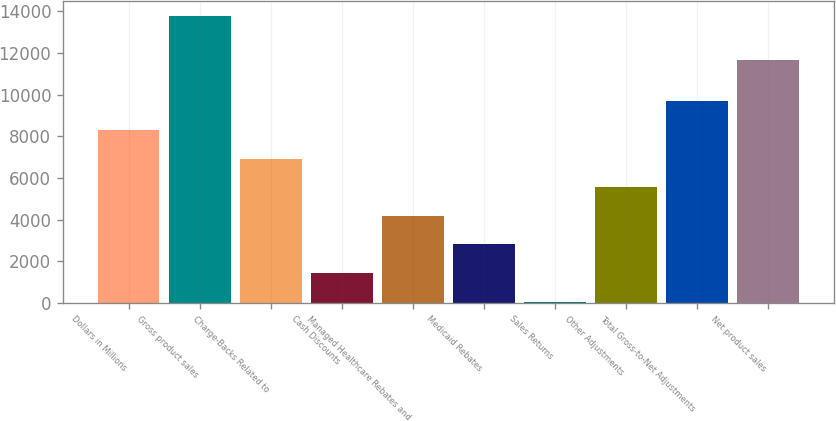Convert chart to OTSL. <chart><loc_0><loc_0><loc_500><loc_500><bar_chart><fcel>Dollars in Millions<fcel>Gross product sales<fcel>Charge-Backs Related to<fcel>Cash Discounts<fcel>Managed Healthcare Rebates and<fcel>Medicaid Rebates<fcel>Sales Returns<fcel>Other Adjustments<fcel>Total Gross-to-Net Adjustments<fcel>Net product sales<nl><fcel>8300.2<fcel>13793<fcel>6927<fcel>1434.2<fcel>4180.6<fcel>2807.4<fcel>61<fcel>5553.8<fcel>9673.4<fcel>11660<nl></chart> 